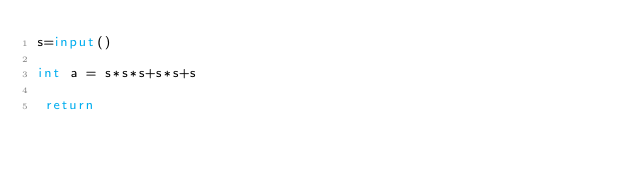<code> <loc_0><loc_0><loc_500><loc_500><_Python_>s=input()

int a = s*s*s+s*s+s

 return</code> 